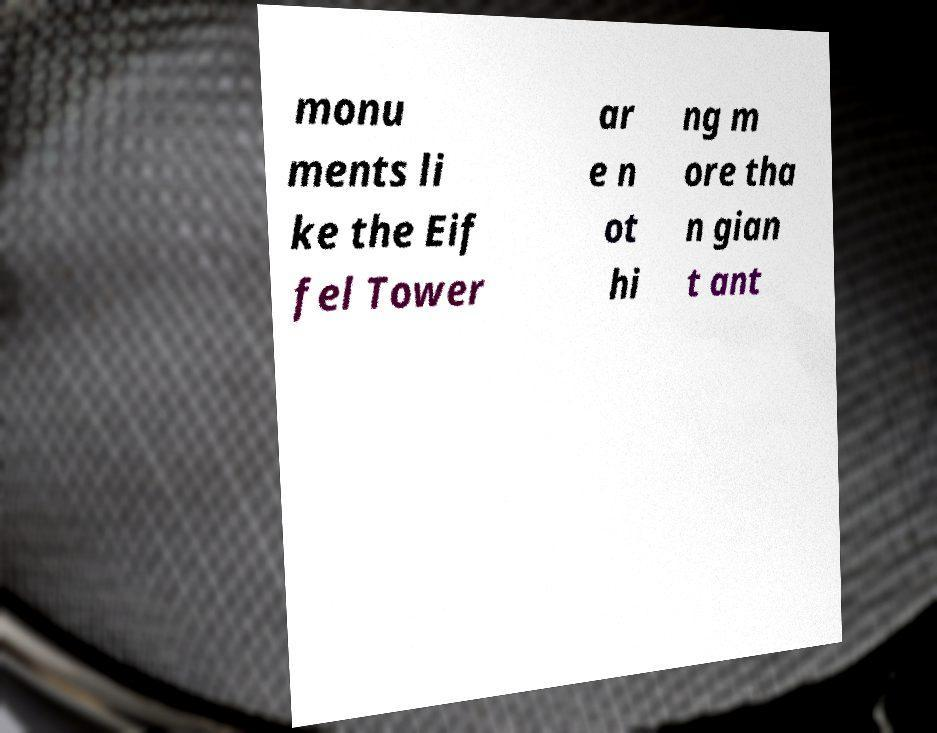Can you accurately transcribe the text from the provided image for me? monu ments li ke the Eif fel Tower ar e n ot hi ng m ore tha n gian t ant 